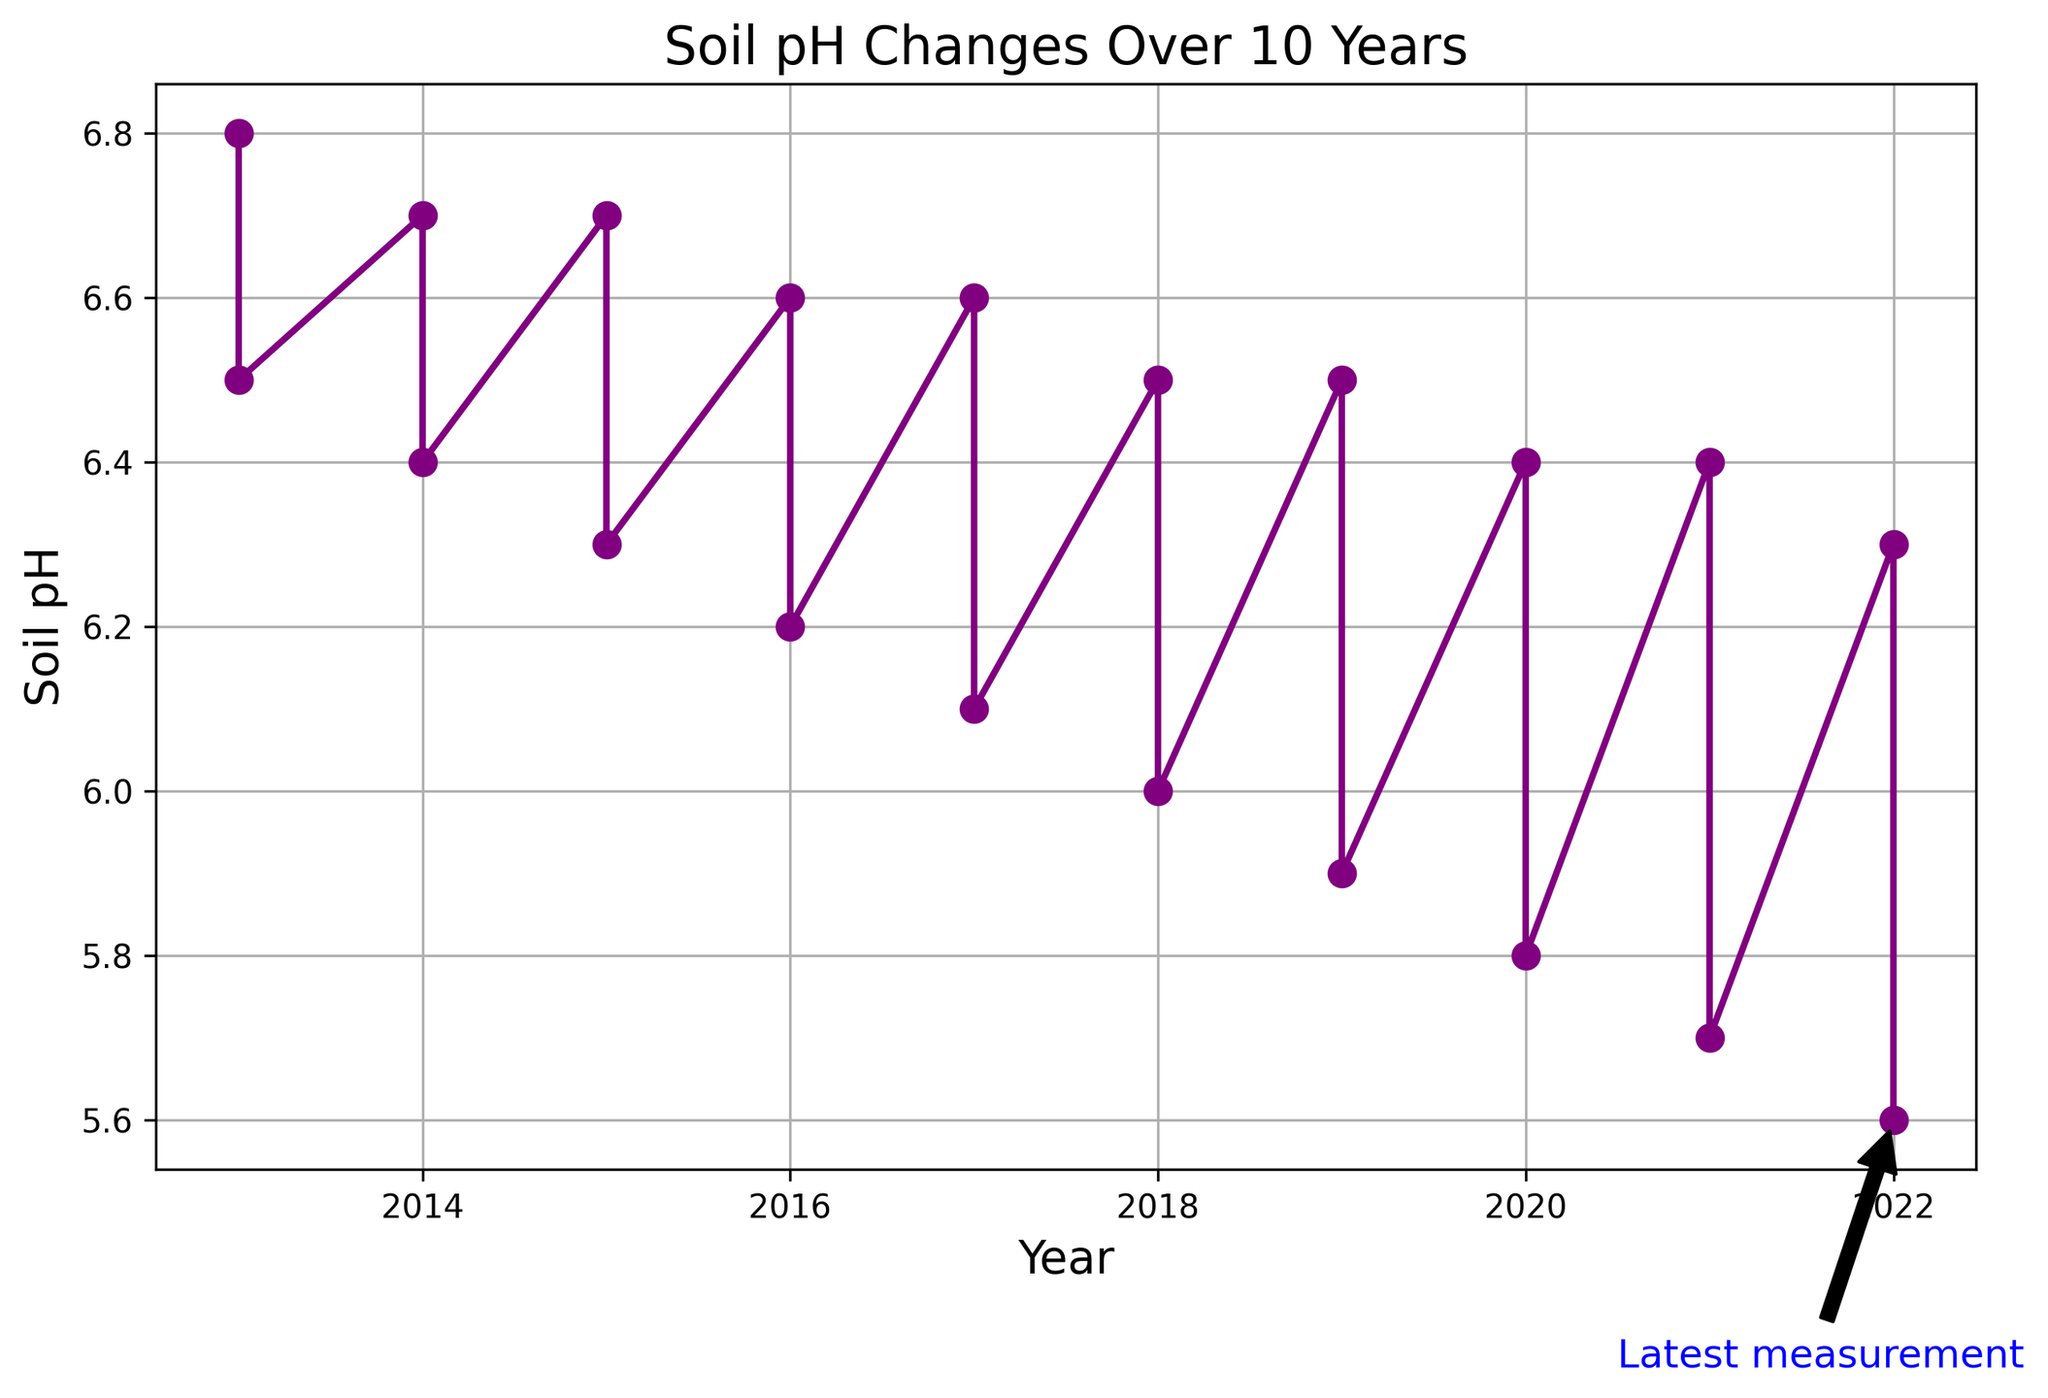What trend can be seen in the soil pH over the 10 years? We observe a general downward trend in soil pH values from 2013 to 2022. This indicates that the soil is becoming more acidic over time.
Answer: Downward trend What is the soil pH value of the latest measurement? The latest measurement, according to the annotation, is in 2022 under Barley in Cycle_2, where the soil pH is 5.6.
Answer: 5.6 Which crop in which cycle shows the highest soil pH value and what is it? By looking over the plot from 2013 to 2022, the highest soil pH value is 6.8, which occurs for Wheat in Cycle_1 in 2013.
Answer: Wheat, Cycle_1, 6.8 How many times did the soil pH decrease from one crop cycle to the next? We count the number of times the soil pH decreases between consecutive data points:
6.8 to 6.5, 6.7 to 6.4, 6.7 to 6.3, 6.6 to 6.2, 6.6 to 6.1, 6.5 to 6.0, 6.5 to 5.9, 6.4 to 5.8, 6.4 to 5.7, 6.3 to 5.6. This gives a total of 10 decreases.
Answer: 10 By how much did the soil pH change from the highest observed value to the lowest observed value? The highest soil pH value is 6.8, and the lowest is 5.6. The difference is 6.8 - 5.6 = 1.2.
Answer: 1.2 Did any crop cycle maintain the same soil pH value from one year to the next? Looking at the plots, there are no instances where the soil pH value remains constant for any crop cycle from one year to the next; it either increased or decreased every year.
Answer: No Which crop cycle experienced the biggest drop in soil pH, and what was the magnitude of this drop? The largest drop in soil pH is between Corn in Cycle_2 in 2013 (6.5) to Corn in Cycle_2 in 2022 (5.7), resulting in a drop of 6.5 - 5.7 = 0.8.
Answer: Corn, Cycle_2, 0.8 